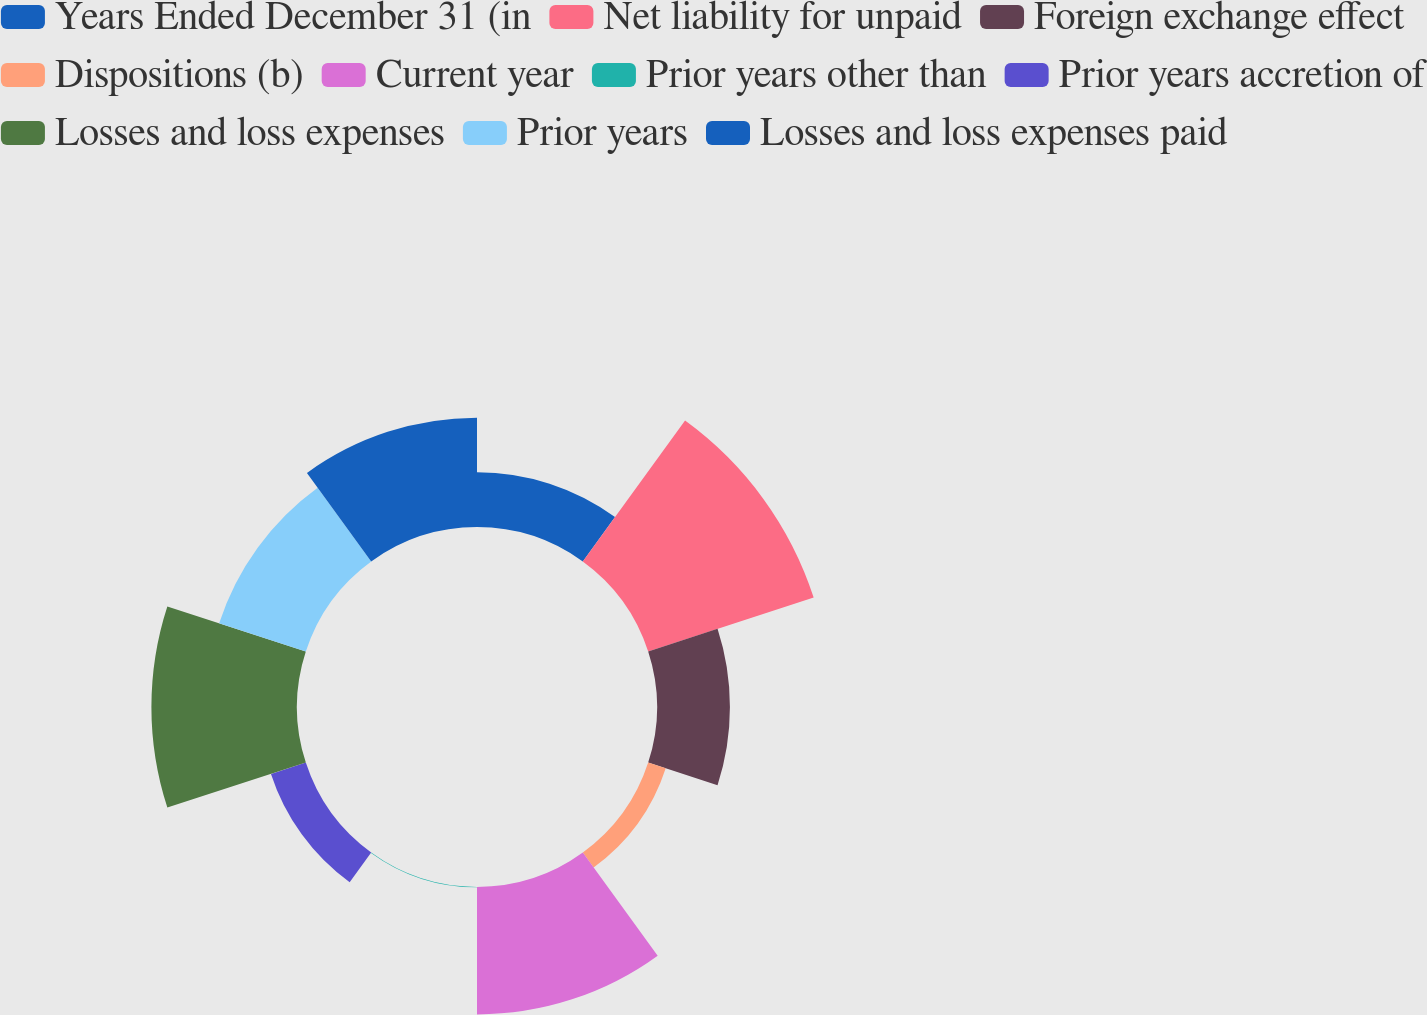<chart> <loc_0><loc_0><loc_500><loc_500><pie_chart><fcel>Years Ended December 31 (in<fcel>Net liability for unpaid<fcel>Foreign exchange effect<fcel>Dispositions (b)<fcel>Current year<fcel>Prior years other than<fcel>Prior years accretion of<fcel>Losses and loss expenses<fcel>Prior years<fcel>Losses and loss expenses paid<nl><fcel>6.6%<fcel>20.95%<fcel>8.78%<fcel>2.22%<fcel>15.34%<fcel>0.04%<fcel>4.41%<fcel>17.53%<fcel>10.97%<fcel>13.16%<nl></chart> 